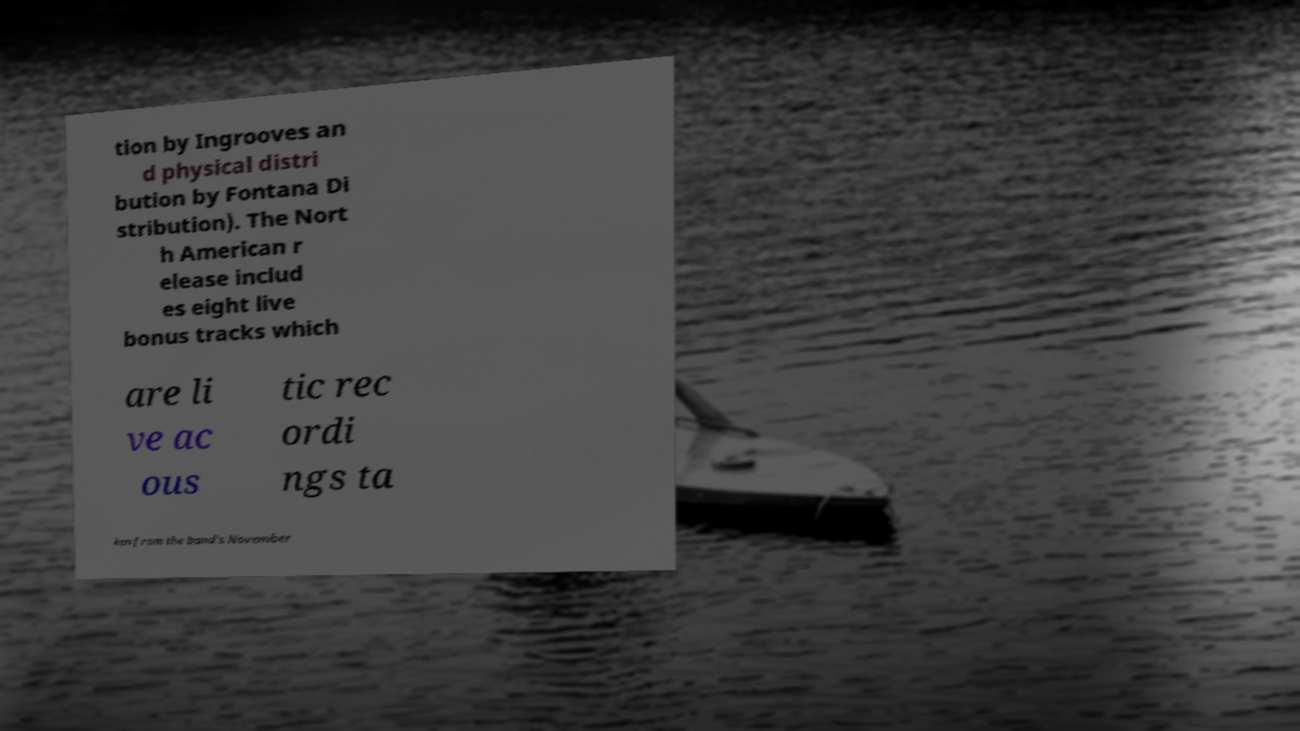What messages or text are displayed in this image? I need them in a readable, typed format. tion by Ingrooves an d physical distri bution by Fontana Di stribution). The Nort h American r elease includ es eight live bonus tracks which are li ve ac ous tic rec ordi ngs ta ken from the band's November 